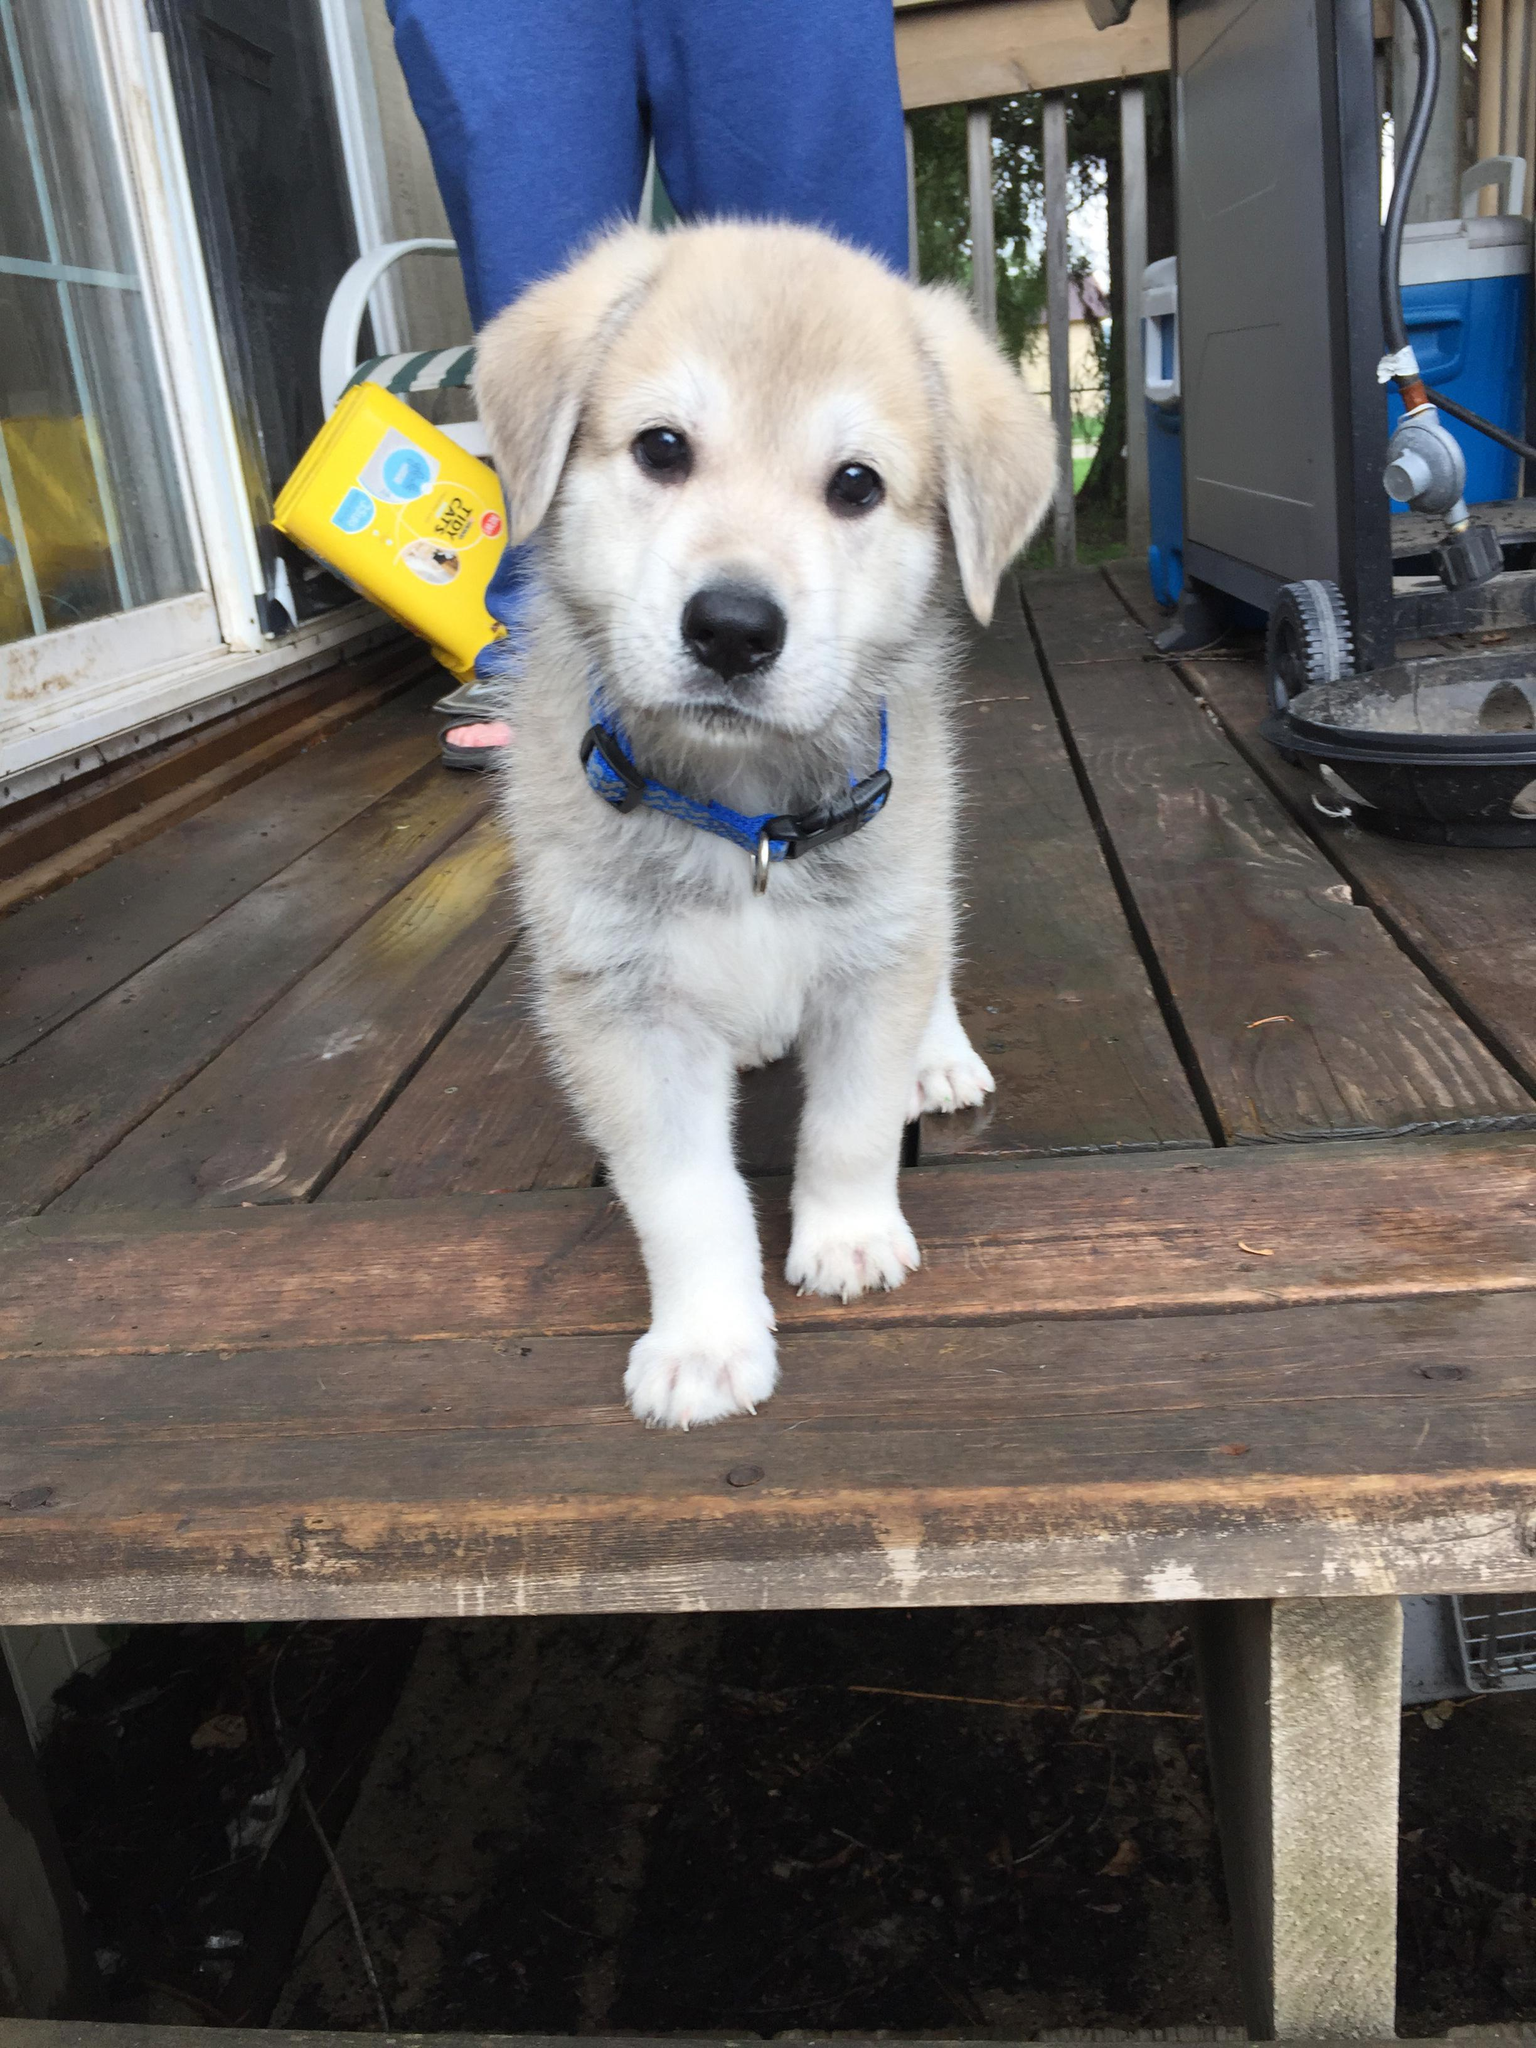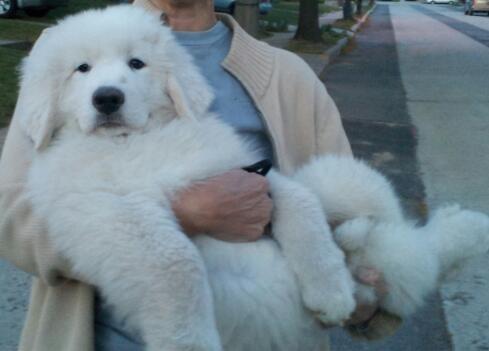The first image is the image on the left, the second image is the image on the right. Analyze the images presented: Is the assertion "The dog in the image on the right is with a human in a vehicle." valid? Answer yes or no. No. The first image is the image on the left, the second image is the image on the right. Given the left and right images, does the statement "An image includes a person wearing jeans inside a vehicle with one white dog." hold true? Answer yes or no. No. 